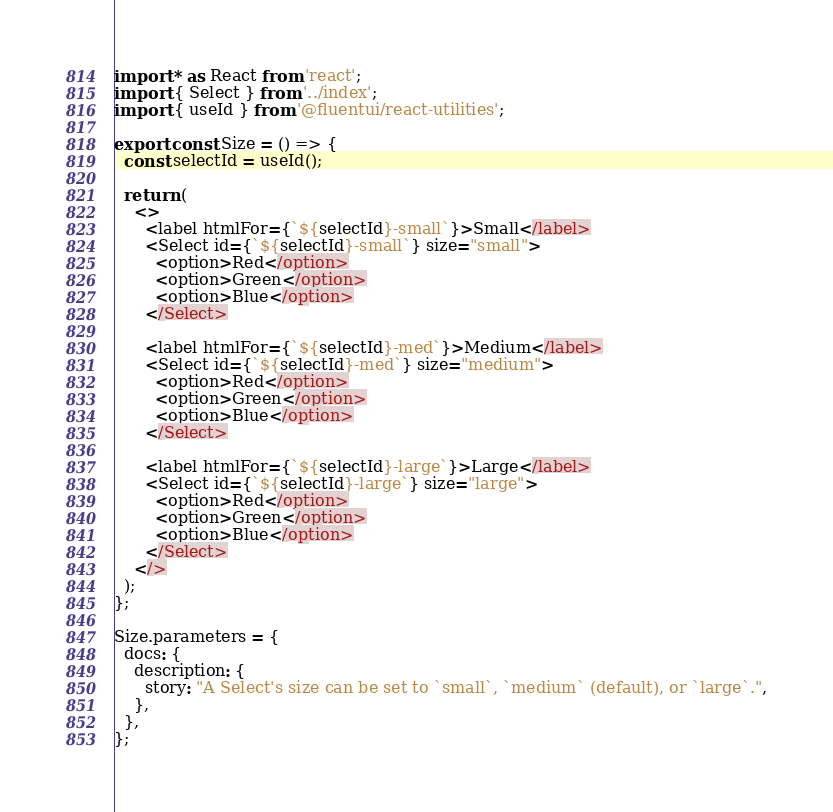Convert code to text. <code><loc_0><loc_0><loc_500><loc_500><_TypeScript_>import * as React from 'react';
import { Select } from '../index';
import { useId } from '@fluentui/react-utilities';

export const Size = () => {
  const selectId = useId();

  return (
    <>
      <label htmlFor={`${selectId}-small`}>Small</label>
      <Select id={`${selectId}-small`} size="small">
        <option>Red</option>
        <option>Green</option>
        <option>Blue</option>
      </Select>

      <label htmlFor={`${selectId}-med`}>Medium</label>
      <Select id={`${selectId}-med`} size="medium">
        <option>Red</option>
        <option>Green</option>
        <option>Blue</option>
      </Select>

      <label htmlFor={`${selectId}-large`}>Large</label>
      <Select id={`${selectId}-large`} size="large">
        <option>Red</option>
        <option>Green</option>
        <option>Blue</option>
      </Select>
    </>
  );
};

Size.parameters = {
  docs: {
    description: {
      story: "A Select's size can be set to `small`, `medium` (default), or `large`.",
    },
  },
};
</code> 